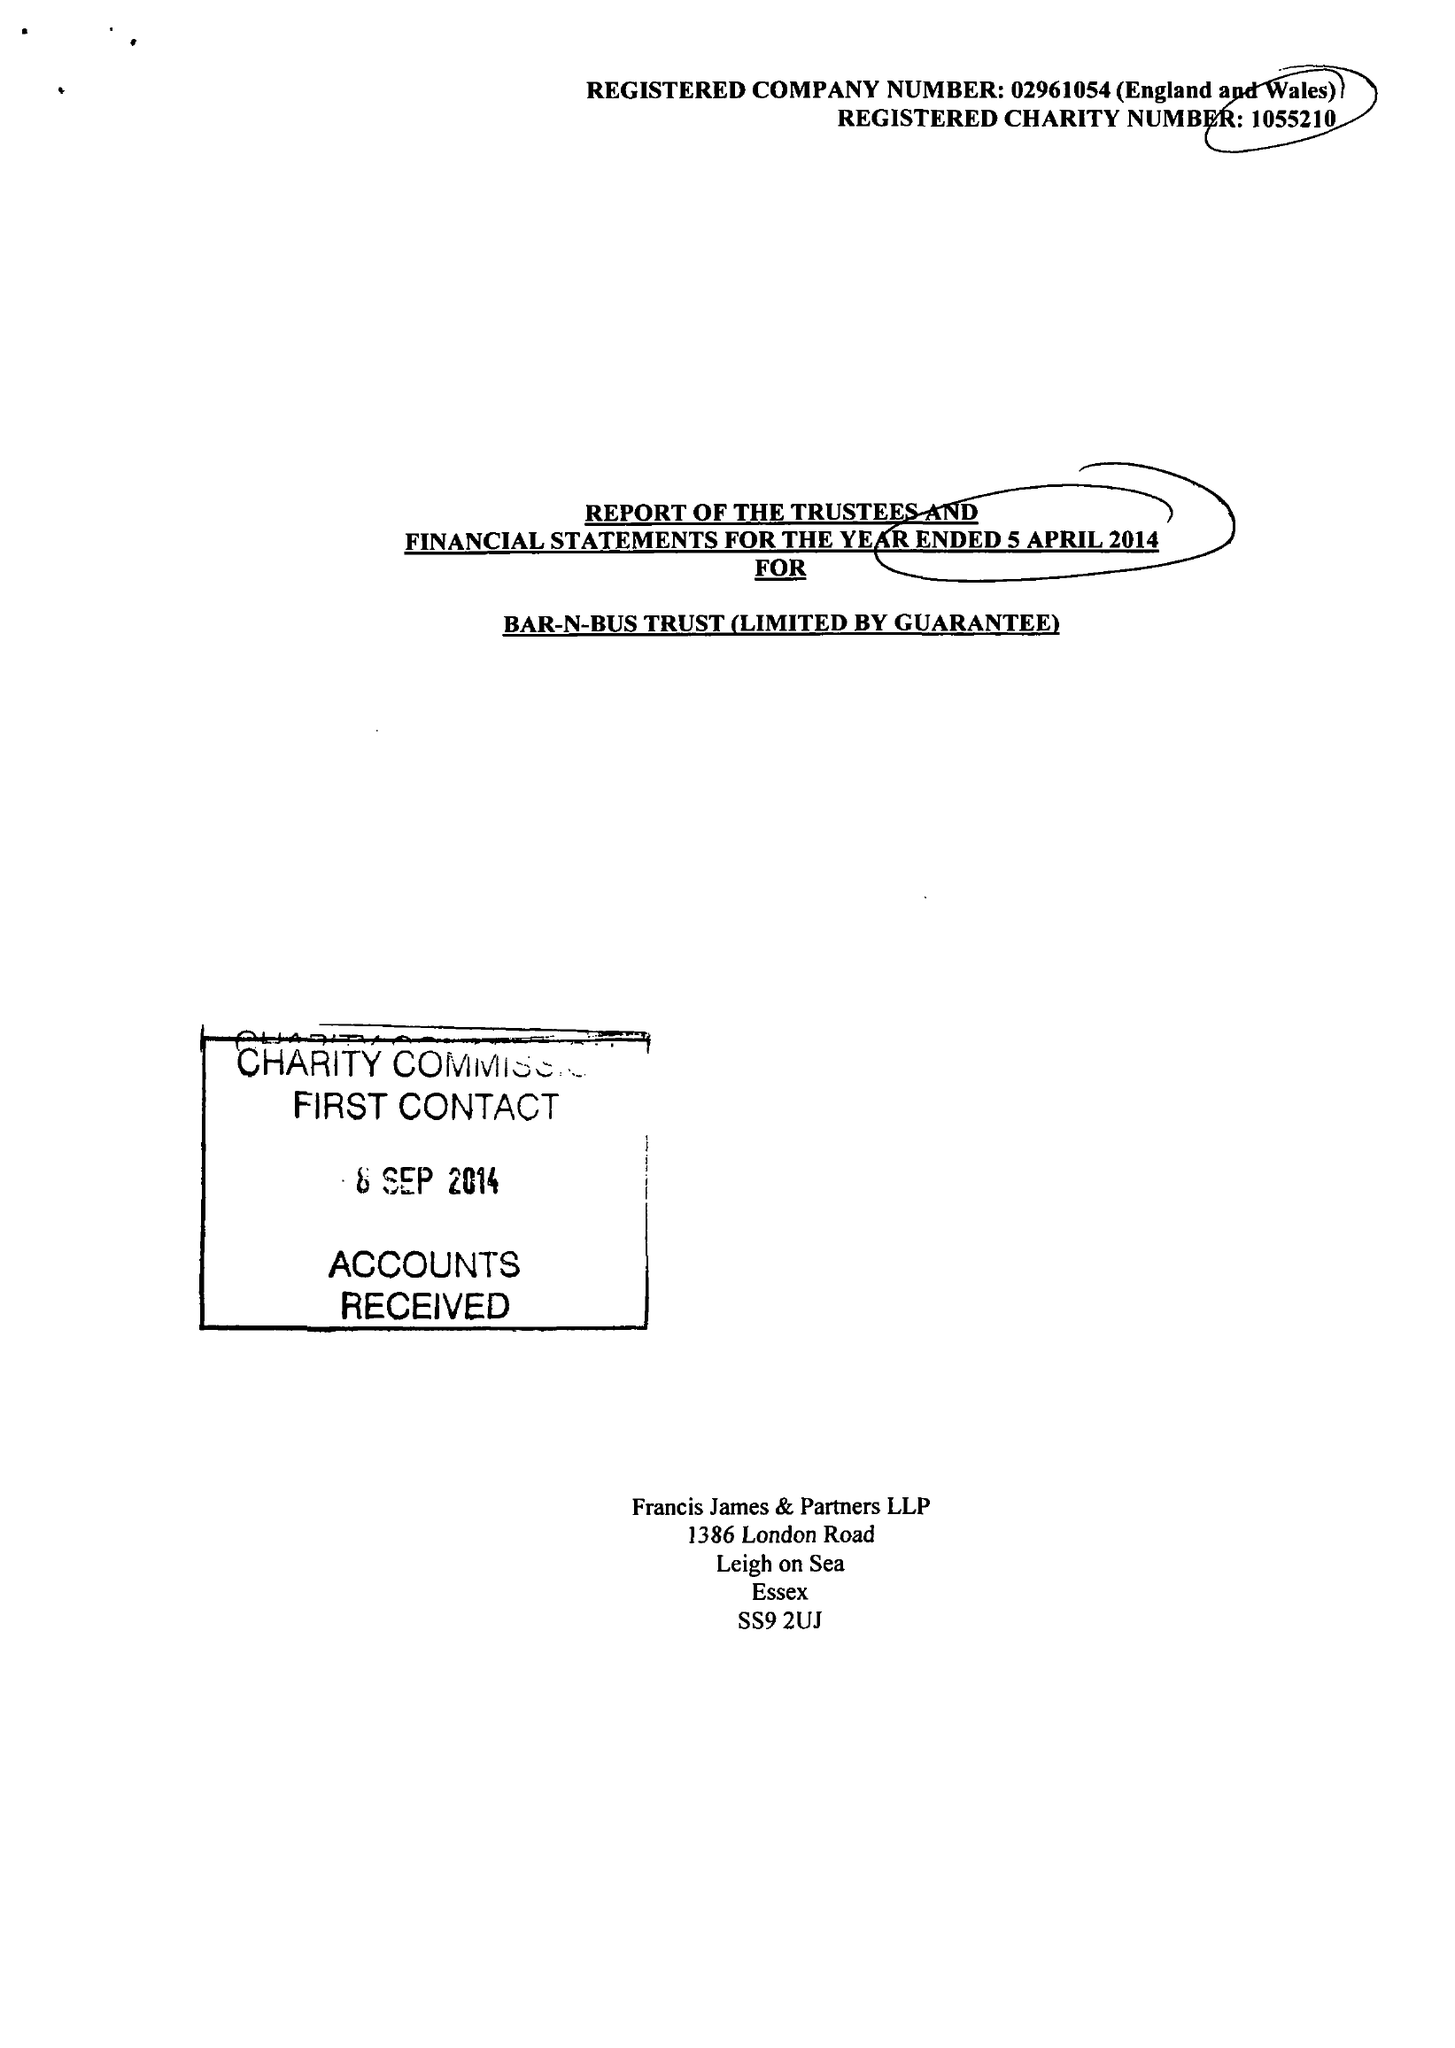What is the value for the report_date?
Answer the question using a single word or phrase. 2014-04-05 